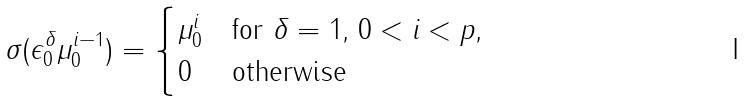Convert formula to latex. <formula><loc_0><loc_0><loc_500><loc_500>\sigma ( \epsilon _ { 0 } ^ { \delta } \mu _ { 0 } ^ { i - 1 } ) = \begin{cases} \mu _ { 0 } ^ { i } & \text {for $\delta=1$, $0<i<p$,} \\ 0 & \text {otherwise} \end{cases}</formula> 